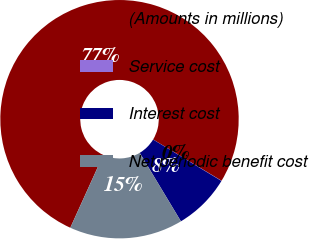Convert chart to OTSL. <chart><loc_0><loc_0><loc_500><loc_500><pie_chart><fcel>(Amounts in millions)<fcel>Service cost<fcel>Interest cost<fcel>Net periodic benefit cost<nl><fcel>76.87%<fcel>0.03%<fcel>7.71%<fcel>15.39%<nl></chart> 